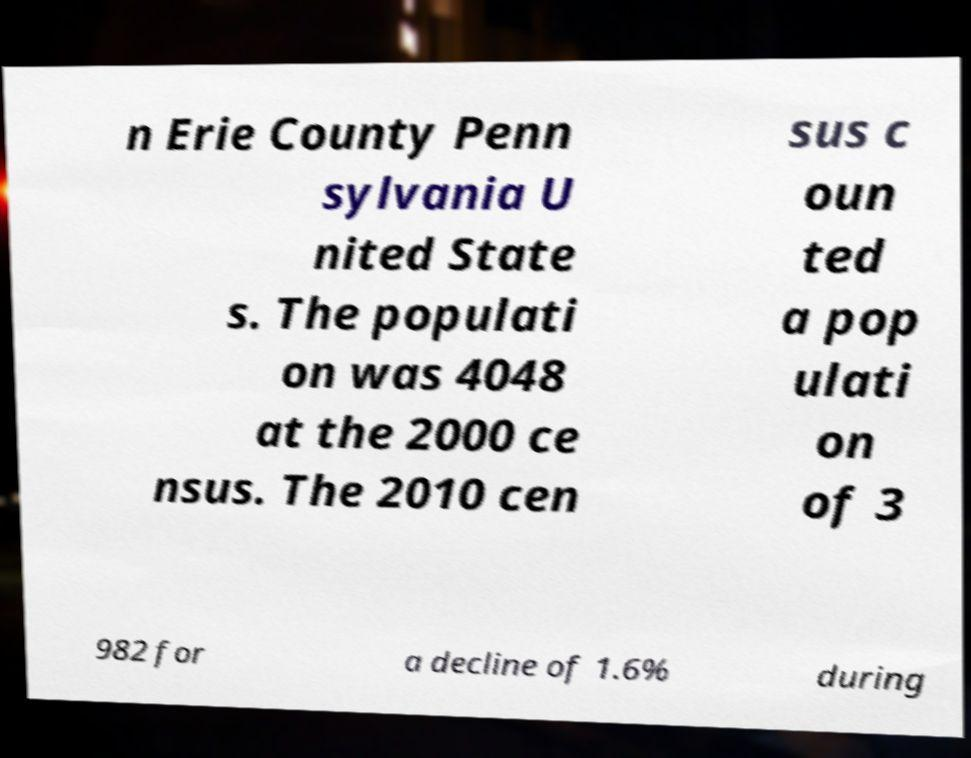Please read and relay the text visible in this image. What does it say? n Erie County Penn sylvania U nited State s. The populati on was 4048 at the 2000 ce nsus. The 2010 cen sus c oun ted a pop ulati on of 3 982 for a decline of 1.6% during 